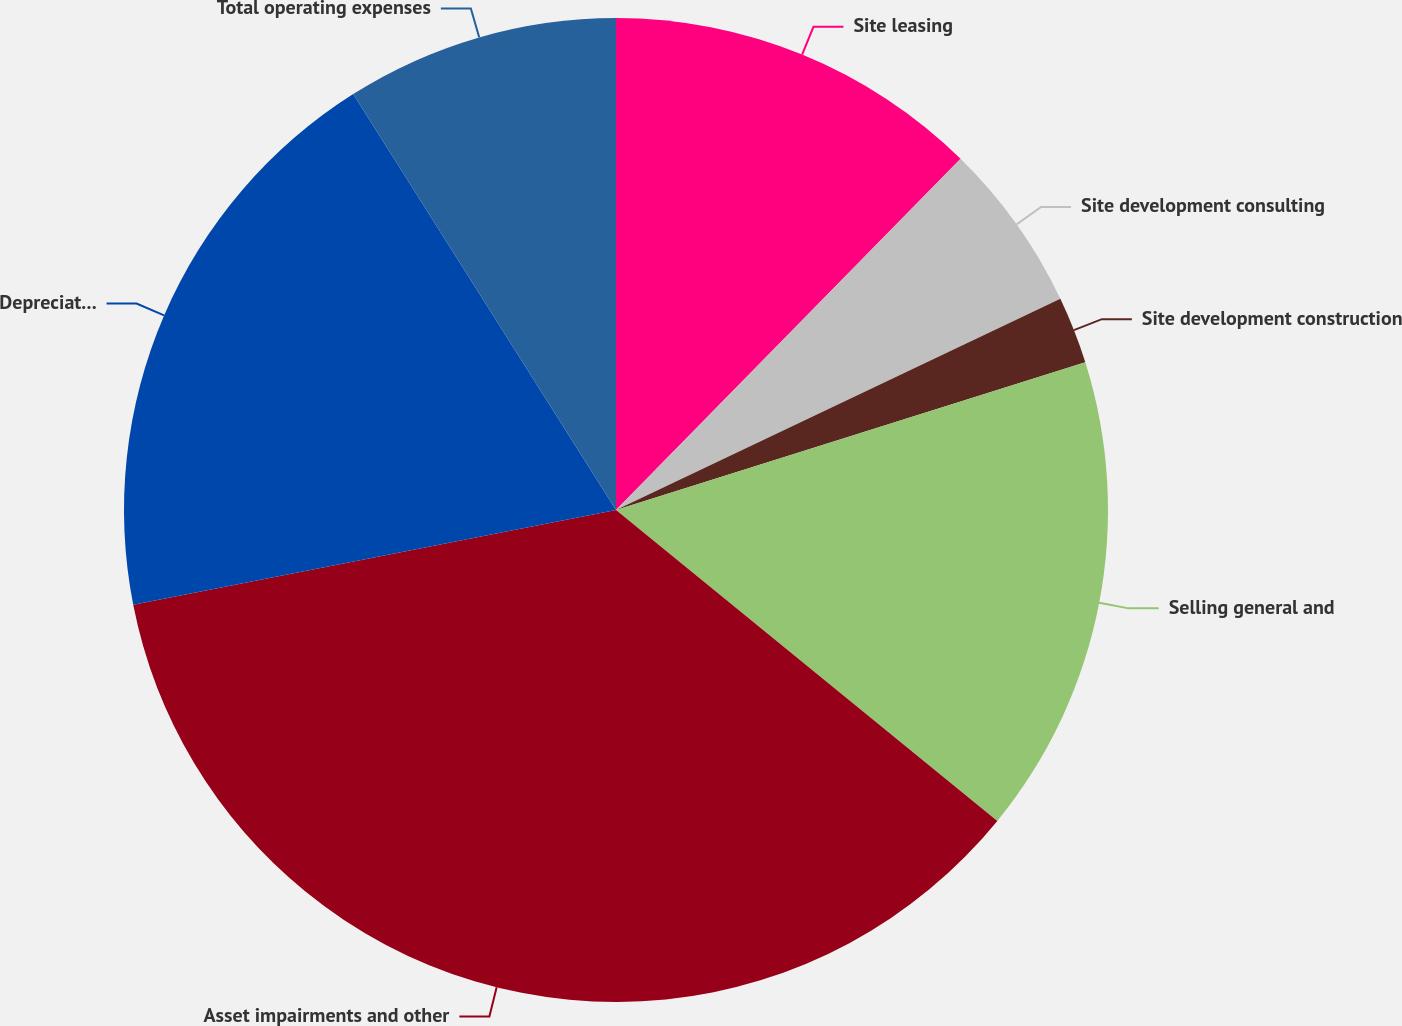Convert chart. <chart><loc_0><loc_0><loc_500><loc_500><pie_chart><fcel>Site leasing<fcel>Site development consulting<fcel>Site development construction<fcel>Selling general and<fcel>Asset impairments and other<fcel>Depreciation accretion and<fcel>Total operating expenses<nl><fcel>12.35%<fcel>5.59%<fcel>2.21%<fcel>15.74%<fcel>36.03%<fcel>19.12%<fcel>8.97%<nl></chart> 